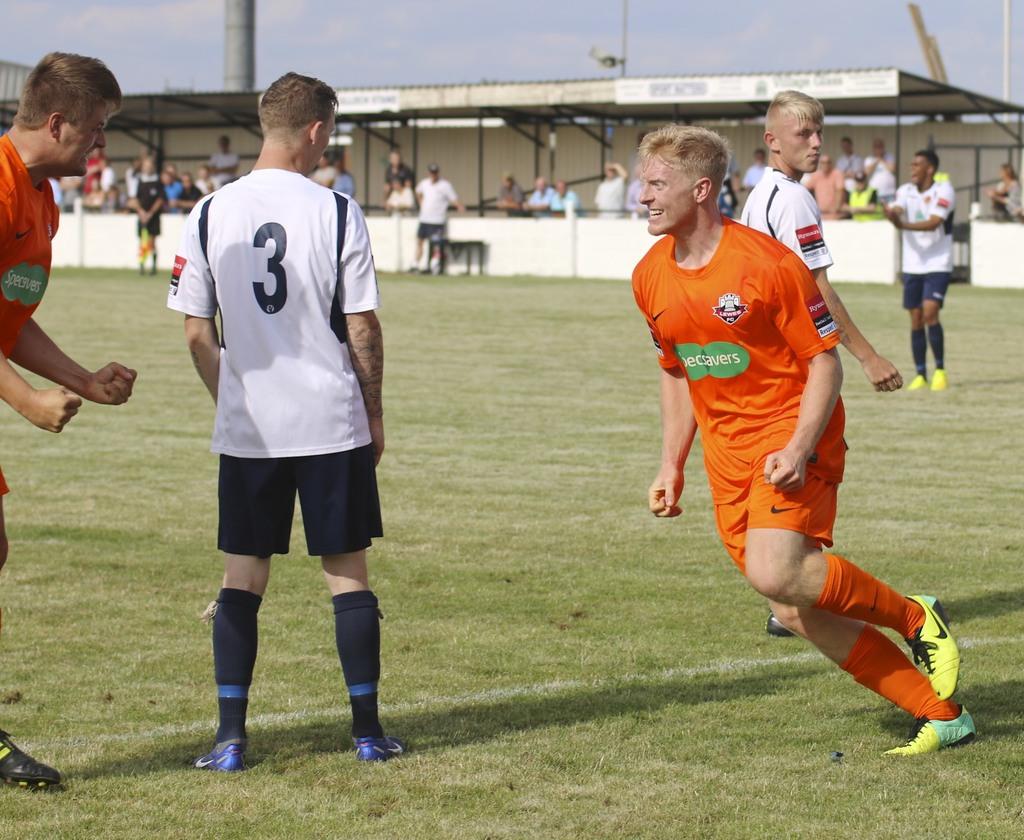What is the number on the white jersey?
Offer a terse response. 3. What is the brand on the center of the orange jersey?
Offer a very short reply. Unanswerable. 